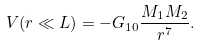Convert formula to latex. <formula><loc_0><loc_0><loc_500><loc_500>V ( r \ll L ) = - G _ { 1 0 } \frac { M _ { 1 } M _ { 2 } } { r ^ { 7 } } .</formula> 